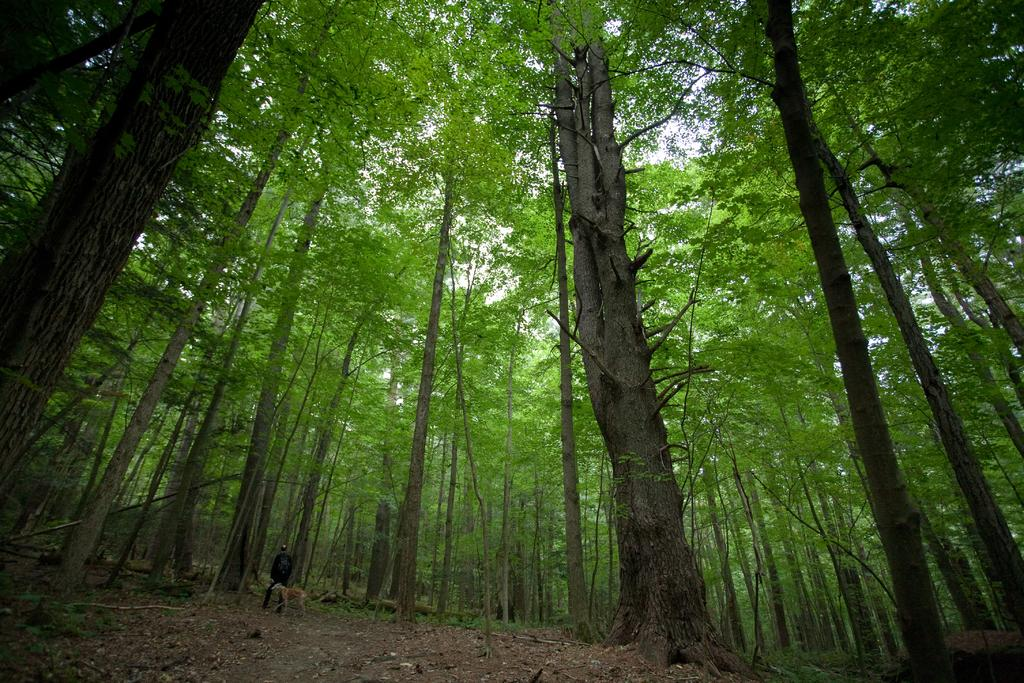Who or what is the main subject in the image? There is a person and an animal in the image. What type of environment is depicted in the image? The image shows trees, grass, and the sky, suggesting a natural setting. Can you describe the animal in the image? Unfortunately, the facts provided do not specify the type of animal in the image. What is the person in the image doing? The facts provided do not specify the actions of the person in the image. How many sisters are present in the image? There is no mention of sisters in the image or the provided facts. What type of test can be seen being conducted in the image? There is no test or testing activity depicted in the image. 